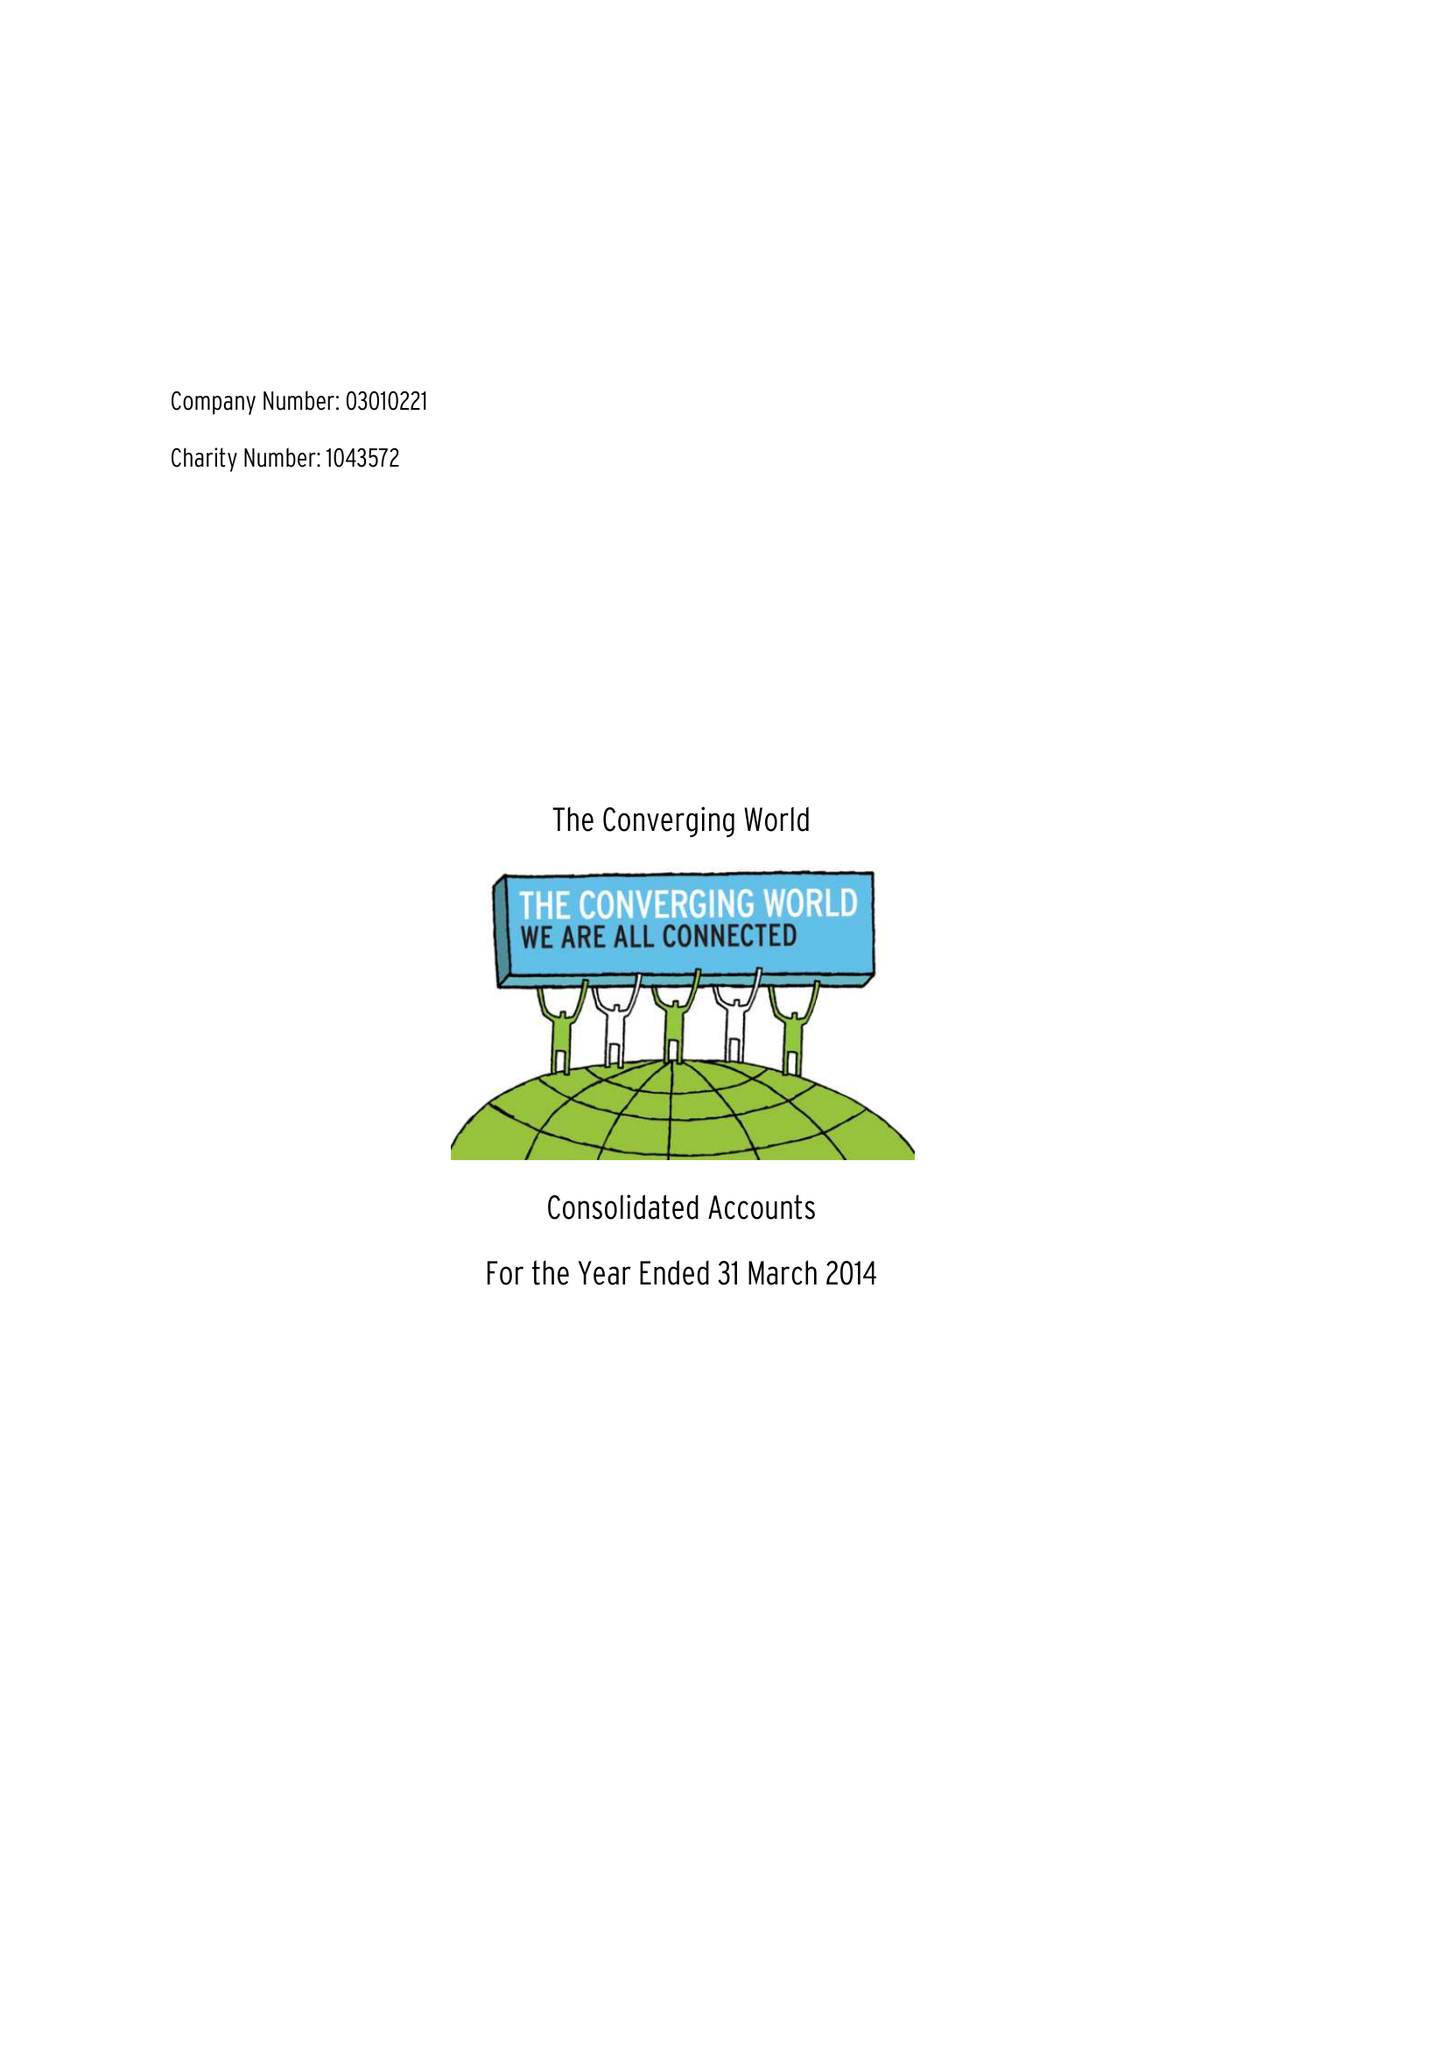What is the value for the spending_annually_in_british_pounds?
Answer the question using a single word or phrase. 238267.00 